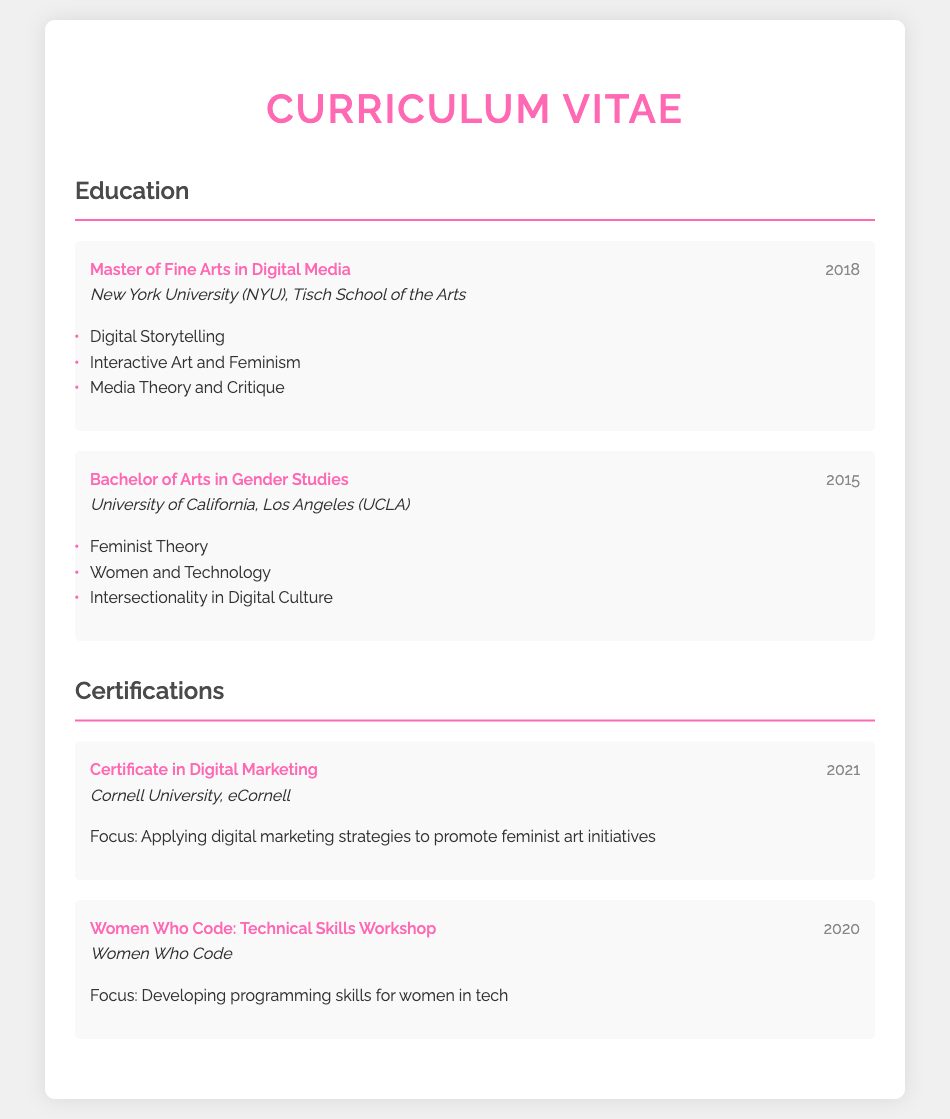What degree was obtained in 2018? The document lists a Master of Fine Arts in Digital Media as the degree obtained in 2018.
Answer: Master of Fine Arts in Digital Media Where did the author complete their Bachelor's degree? The document states that the Bachelor's degree was completed at the University of California, Los Angeles (UCLA).
Answer: University of California, Los Angeles (UCLA) What was the focus of the Certificate obtained in 2021? The document indicates that the focus of the 2021 Certificate was on applying digital marketing strategies to promote feminist art initiatives.
Answer: Applying digital marketing strategies to promote feminist art initiatives Which workshop did the author attend in 2020? The document names the Women Who Code: Technical Skills Workshop as the workshop attended in 2020.
Answer: Women Who Code: Technical Skills Workshop What year did the author earn a Master's degree? According to the document, the author earned a Master's degree in 2018.
Answer: 2018 List one relevant coursework from the Master's degree. The document provides Digital Storytelling as one relevant coursework from the Master's degree.
Answer: Digital Storytelling What is one certification mentioned in the document? One certification mentioned is the Certificate in Digital Marketing.
Answer: Certificate in Digital Marketing How many years apart are the Bachelor's and Master's degrees? The document shows that the Bachelor's degree was obtained in 2015 and the Master's in 2018, which is a difference of 3 years.
Answer: 3 years What is the primary theme of the blog content described? The blog content focuses on the intersection of feminism and technology in the art world.
Answer: Feminism and technology in the art world 